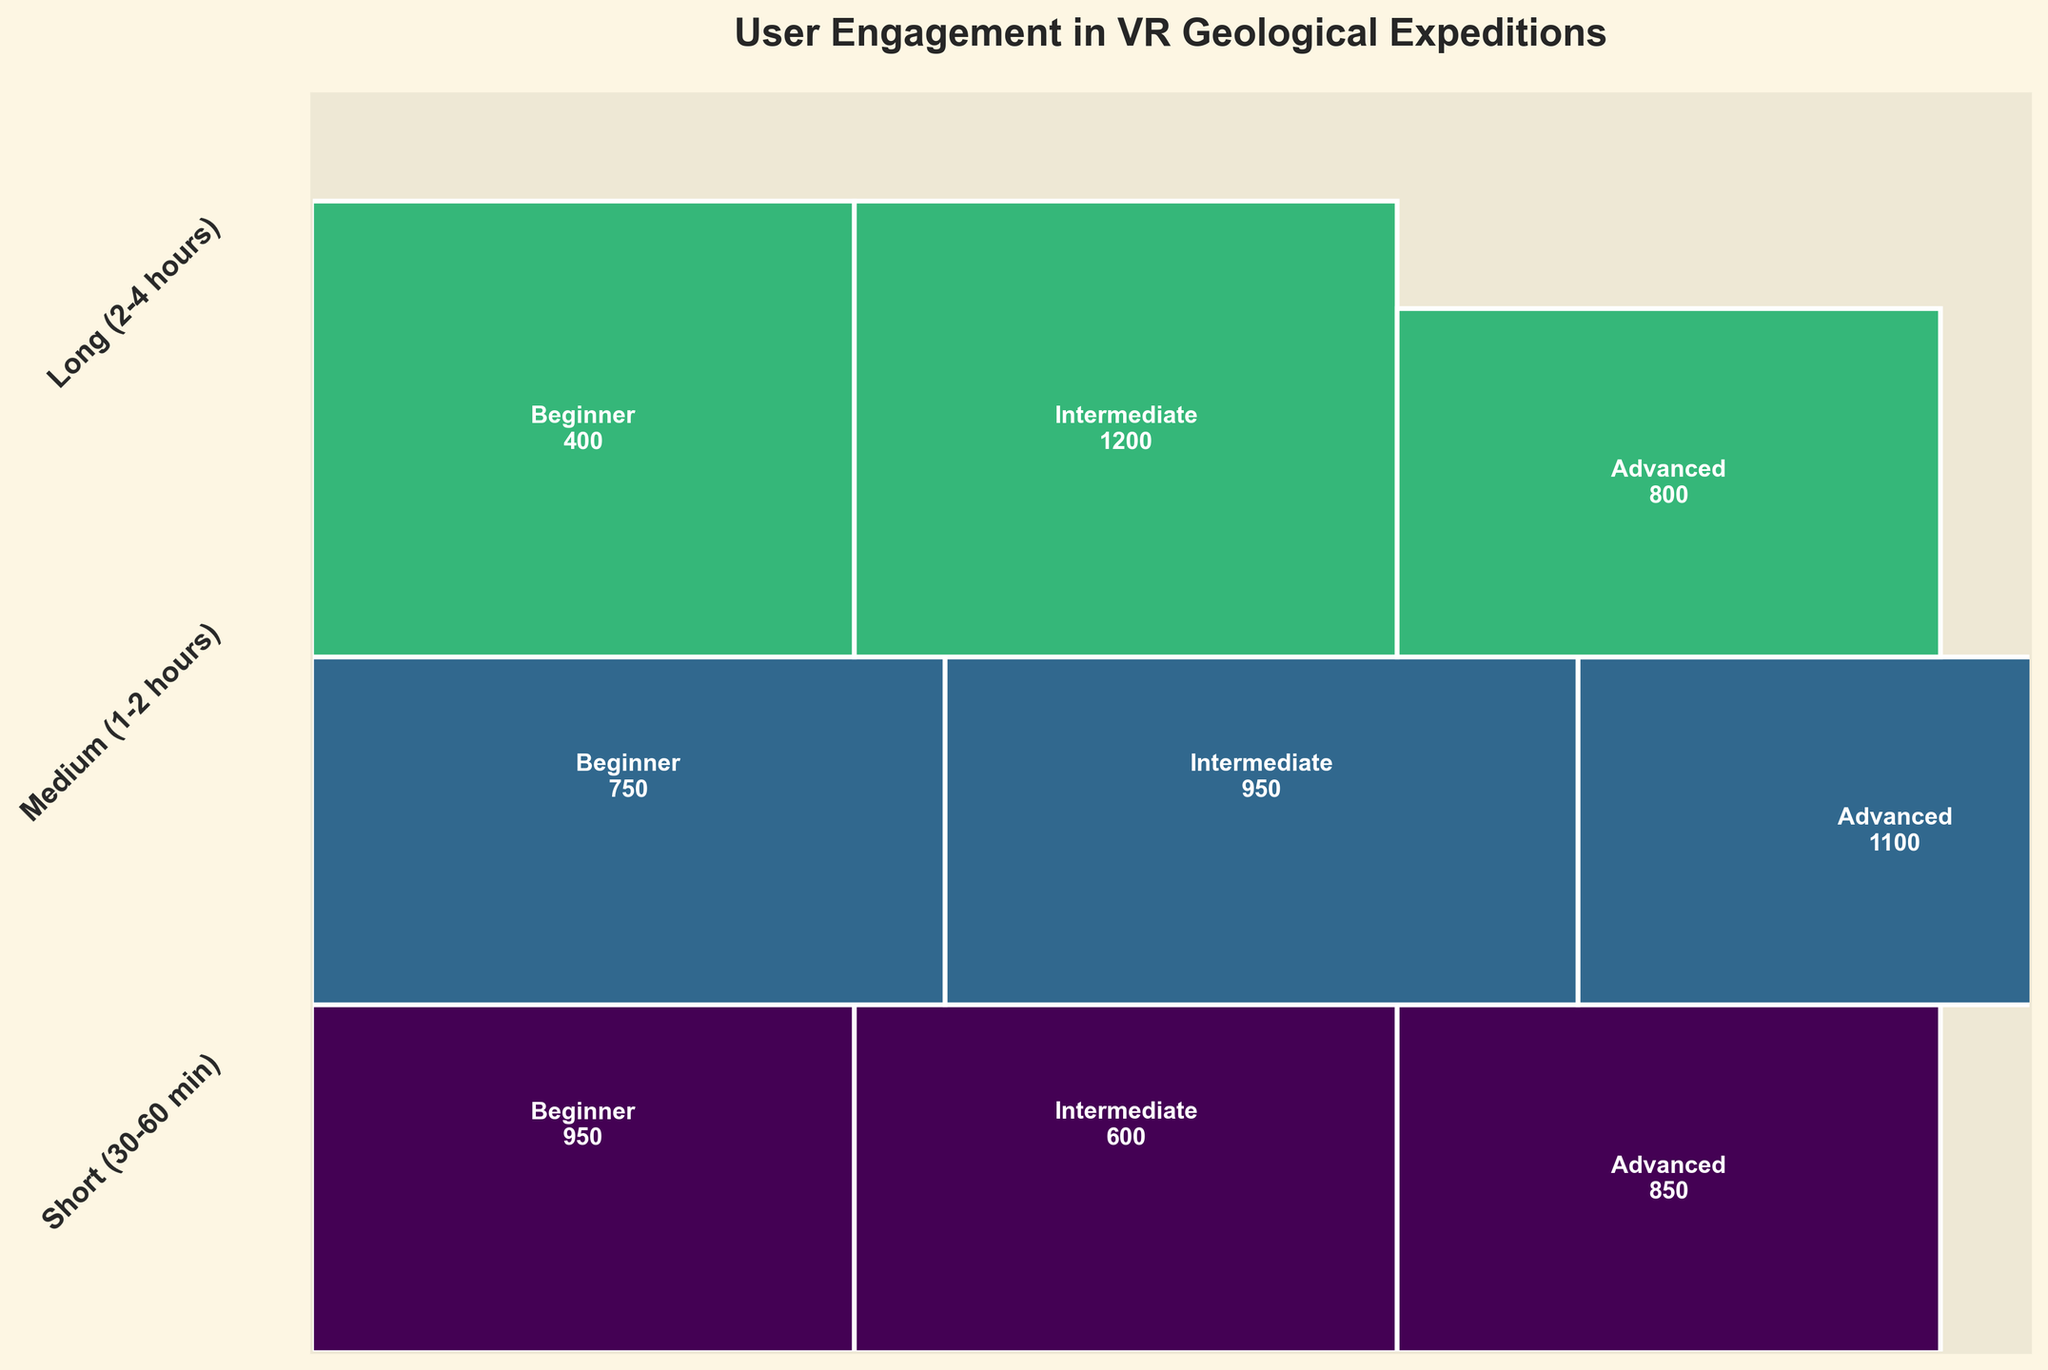What is the title of the figure? The title of the figure is at the top, and it reads 'User Engagement in VR Geological Expeditions'.
Answer: User Engagement in VR Geological Expeditions How many distinct difficulty levels are represented in the plot? The plot visually differentiates three distinct difficulty levels which are labeled within each rectangle: Beginner, Intermediate, and Advanced.
Answer: 3 Which simulation duration has the largest proportion of users? The width of each rectangle segment corresponds to the proportion of users for each simulation duration. The 'Short (30-60 min)' duration clearly has the widest segments, indicating the largest proportion of users.
Answer: Short (30-60 min) Of the given difficulty levels, which one had the most users for 'Long (2-4 hours)' duration? The heights within the 'Long (2-4 hours)' width segment show the proportions of users for each difficulty level. The 'Advanced' segment appears the tallest, indicating it had the most users.
Answer: Advanced What is the combined proportion of users for the Intermediate difficulty level across all durations? To find the combined proportion, sum the widths of the Intermediate segments across all durations. They add up to form the combined proportion for 'Intermediate'.
Answer: sum of Intermediate widths Do users prefer shorter or longer simulation durations? By comparing the widths of each duration category, the 'Short (30-60 min)' and 'Medium (1-2 hours)' durations have wider segments than the 'Long (2-4 hours)' segment, indicating a preference for shorter to medium durations.
Answer: Shorter or Medium Among Intermediate and Advanced difficulty levels, which has a higher completion rate for 'Medium (1-2 hours)' duration? To compare, find the labeled average session time for both difficulty levels within the 'Medium (1-2 hours)' duration. The 'Intermediate' level has a lower average session time of 95 minutes compared to 110 minutes for 'Advanced', suggesting a higher completion rate.
Answer: Intermediate Which difficulty level had the highest average session time for any duration? By identifying and comparing the average session times denoted within each rectangle for each difficulty level across all durations, the 'Advanced' level in the 'Long (2-4 hours)' duration has the highest with 195 minutes.
Answer: Advanced for Long (2-4 hours) 